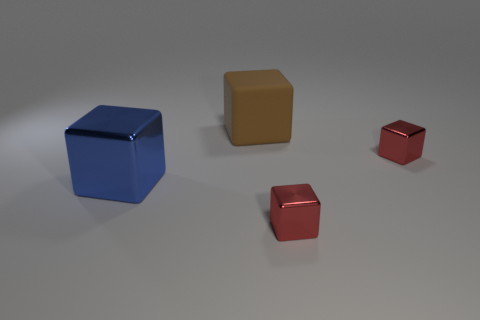Is the size of the shiny object that is behind the blue thing the same as the large blue shiny thing?
Give a very brief answer. No. Is the number of small red metallic blocks greater than the number of small green cubes?
Give a very brief answer. Yes. What number of small things are cubes or red shiny objects?
Keep it short and to the point. 2. How many other things are there of the same color as the large matte block?
Provide a succinct answer. 0. What number of small red cubes have the same material as the big brown block?
Make the answer very short. 0. Do the tiny metal object that is behind the large metallic thing and the large metal cube have the same color?
Provide a succinct answer. No. How many cyan things are either large cubes or metal cubes?
Your answer should be very brief. 0. Are there any other things that are the same material as the big brown block?
Your response must be concise. No. Does the large cube to the left of the big matte thing have the same material as the brown object?
Give a very brief answer. No. How many objects are either brown objects or small red shiny objects behind the large metal object?
Provide a short and direct response. 2. 